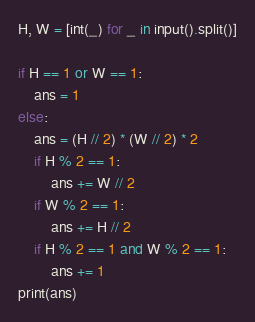<code> <loc_0><loc_0><loc_500><loc_500><_Python_>H, W = [int(_) for _ in input().split()]

if H == 1 or W == 1:
    ans = 1
else:
    ans = (H // 2) * (W // 2) * 2
    if H % 2 == 1:
        ans += W // 2
    if W % 2 == 1:
        ans += H // 2
    if H % 2 == 1 and W % 2 == 1:
        ans += 1
print(ans)
</code> 